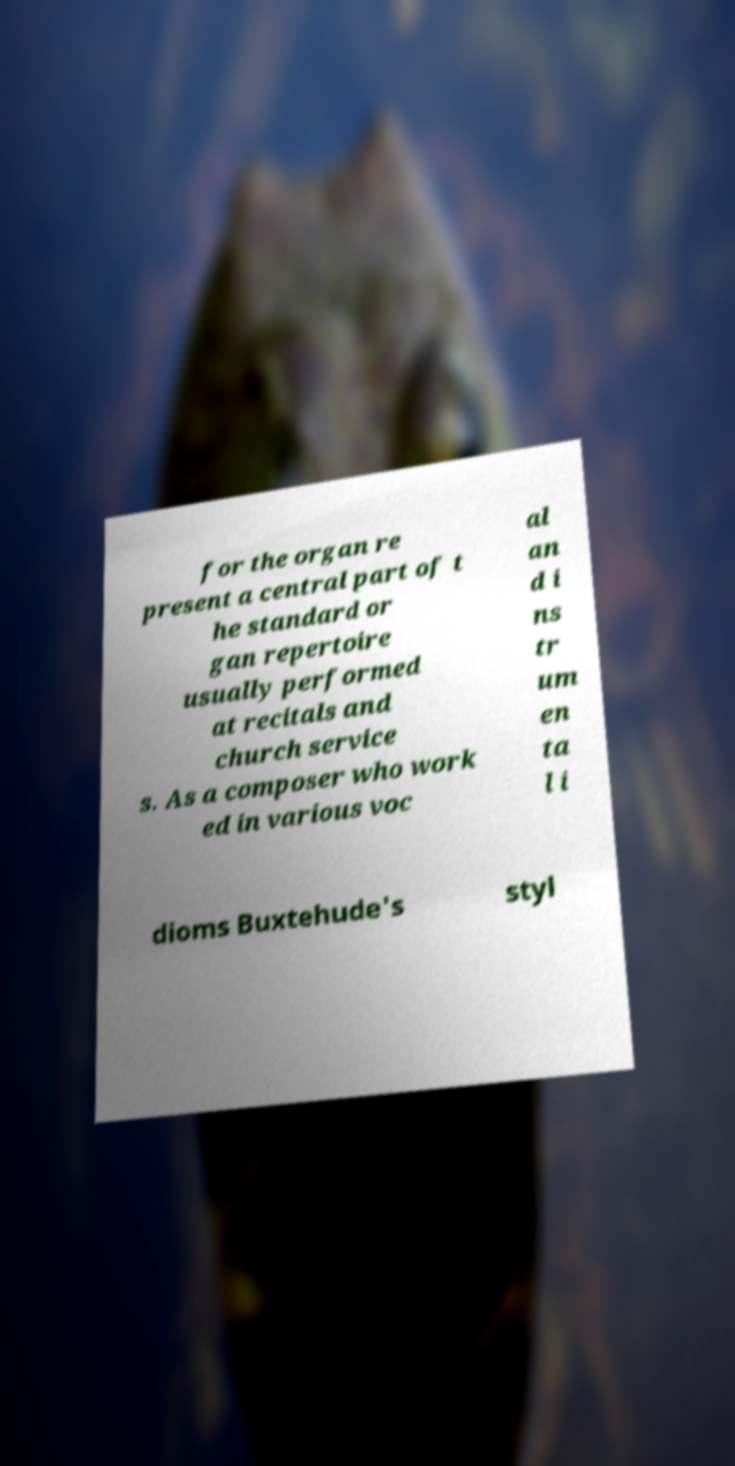For documentation purposes, I need the text within this image transcribed. Could you provide that? for the organ re present a central part of t he standard or gan repertoire usually performed at recitals and church service s. As a composer who work ed in various voc al an d i ns tr um en ta l i dioms Buxtehude's styl 